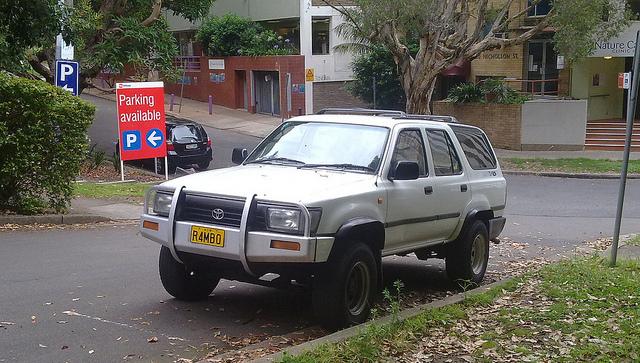How many cars are parked on the street?
Give a very brief answer. 2. Where is the truck parked?
Keep it brief. Street. What make of car is this?
Answer briefly. Toyota. Will the truck be able to move forward?
Short answer required. Yes. What kind of plants are growing by the building?
Write a very short answer. Shrubs. Is this license plate made in the U.S.A.?
Be succinct. No. Is this car parked properly?
Answer briefly. Yes. Could this be in a tropical country?
Write a very short answer. No. How many parking meters are combined?
Write a very short answer. 0. Is there a parking meter?
Concise answer only. No. 